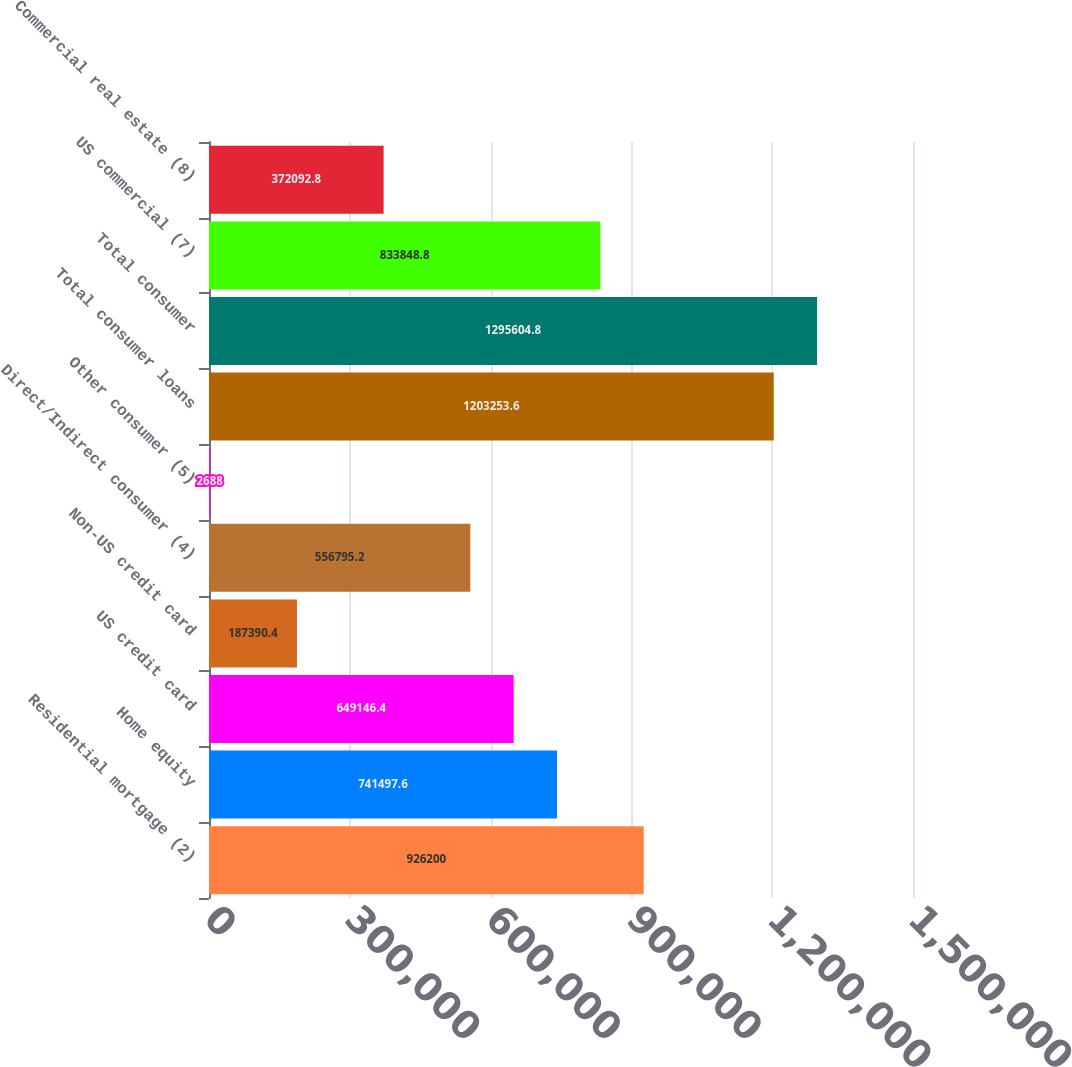Convert chart to OTSL. <chart><loc_0><loc_0><loc_500><loc_500><bar_chart><fcel>Residential mortgage (2)<fcel>Home equity<fcel>US credit card<fcel>Non-US credit card<fcel>Direct/Indirect consumer (4)<fcel>Other consumer (5)<fcel>Total consumer loans<fcel>Total consumer<fcel>US commercial (7)<fcel>Commercial real estate (8)<nl><fcel>926200<fcel>741498<fcel>649146<fcel>187390<fcel>556795<fcel>2688<fcel>1.20325e+06<fcel>1.2956e+06<fcel>833849<fcel>372093<nl></chart> 